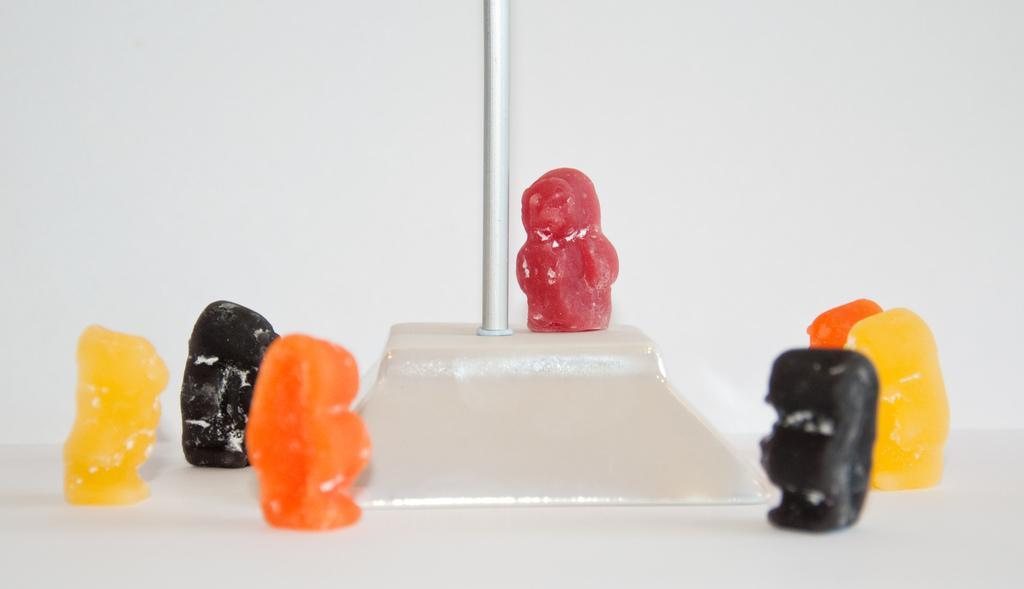Please provide a concise description of this image. This image looks like there are some candies. They are of black, orange, red and yellow color. There is something like a pole in the middle. 